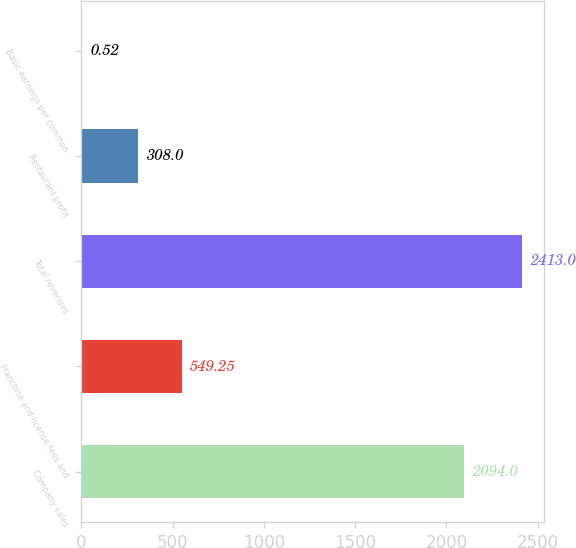<chart> <loc_0><loc_0><loc_500><loc_500><bar_chart><fcel>Company sales<fcel>Franchise and license fees and<fcel>Total revenues<fcel>Restaurant profit<fcel>Basic earnings per common<nl><fcel>2094<fcel>549.25<fcel>2413<fcel>308<fcel>0.52<nl></chart> 